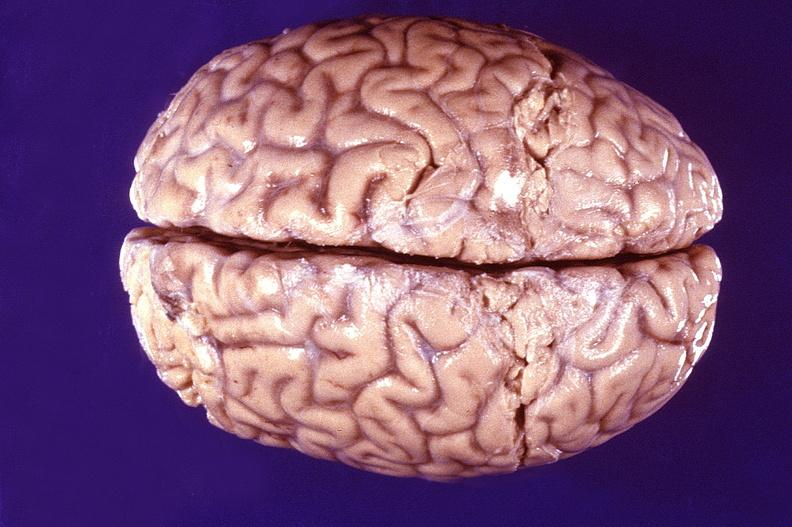does this image show normal brain?
Answer the question using a single word or phrase. Yes 